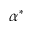Convert formula to latex. <formula><loc_0><loc_0><loc_500><loc_500>\alpha ^ { * }</formula> 